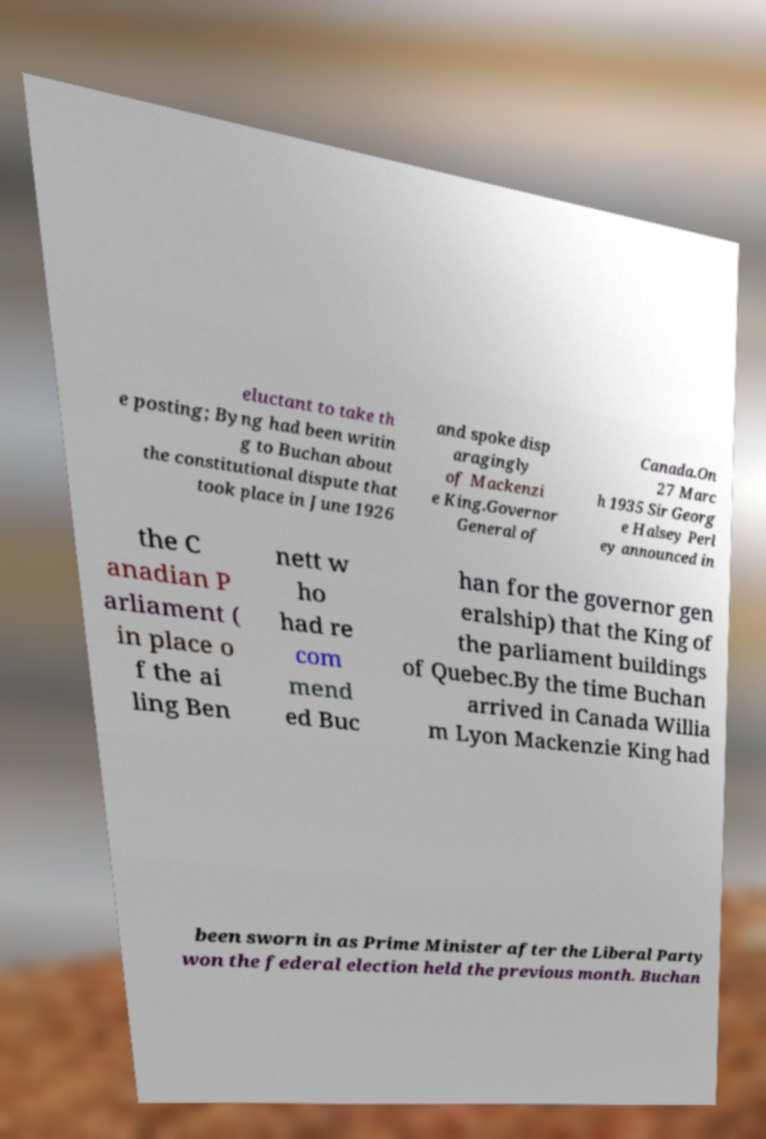Could you assist in decoding the text presented in this image and type it out clearly? eluctant to take th e posting; Byng had been writin g to Buchan about the constitutional dispute that took place in June 1926 and spoke disp aragingly of Mackenzi e King.Governor General of Canada.On 27 Marc h 1935 Sir Georg e Halsey Perl ey announced in the C anadian P arliament ( in place o f the ai ling Ben nett w ho had re com mend ed Buc han for the governor gen eralship) that the King of the parliament buildings of Quebec.By the time Buchan arrived in Canada Willia m Lyon Mackenzie King had been sworn in as Prime Minister after the Liberal Party won the federal election held the previous month. Buchan 